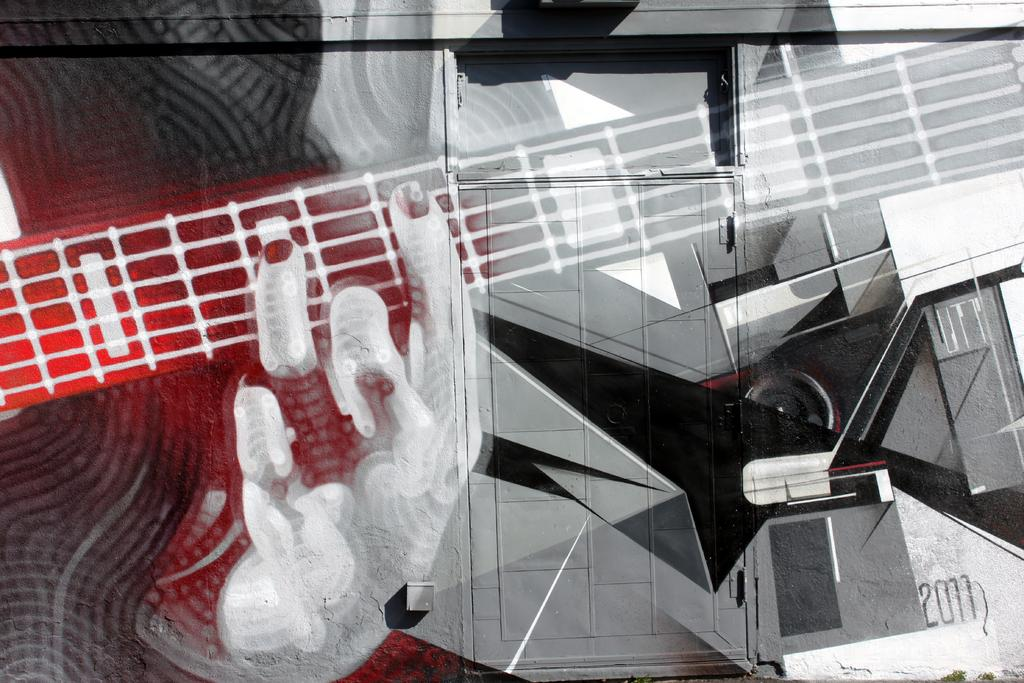Who is the main subject in the image? There is a person in the image. What is the person holding in the image? The person is holding a musical instrument. Can you describe the object that resembles a speaker? Yes, it looks like a speaker, typically used for amplifying sound. What is the person's interest in the image? There is no information provided about the person's interests in the image. Is the person's father present in the image? There is no information provided about the person's father in the image. 